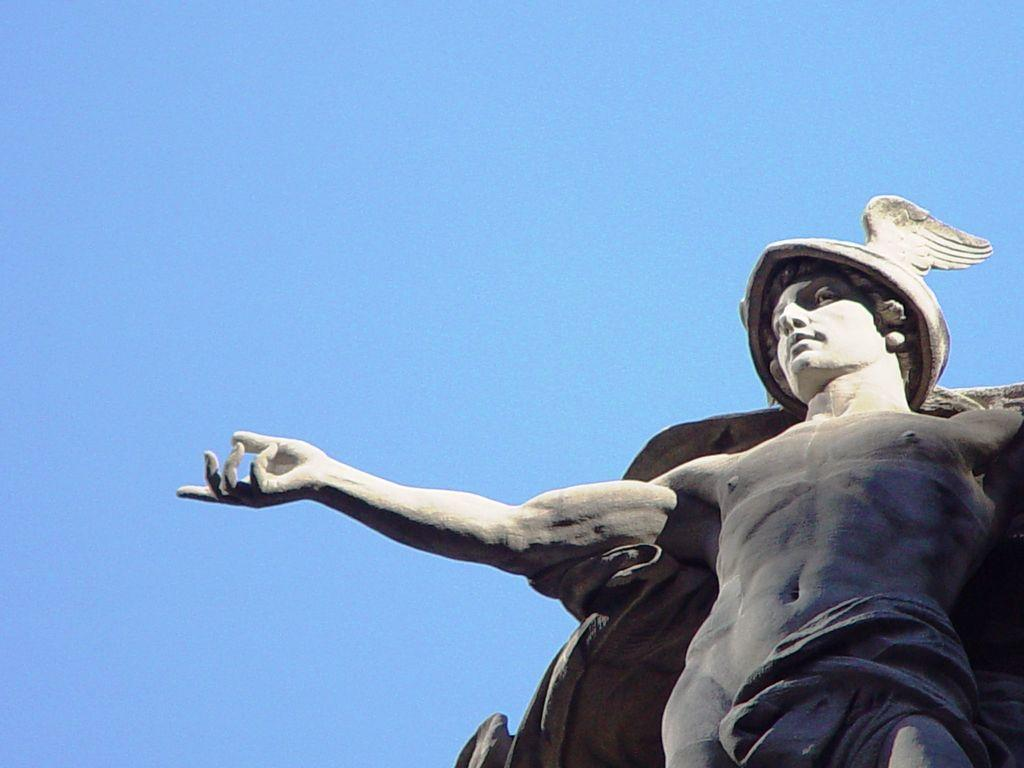What is the main subject of the image? There is a statue of a person in the image. What can be seen in the background of the image? The sky is visible at the top of the image. What type of stick is the scarecrow holding in the image? There is no scarecrow or stick present in the image; it features a statue of a person. 